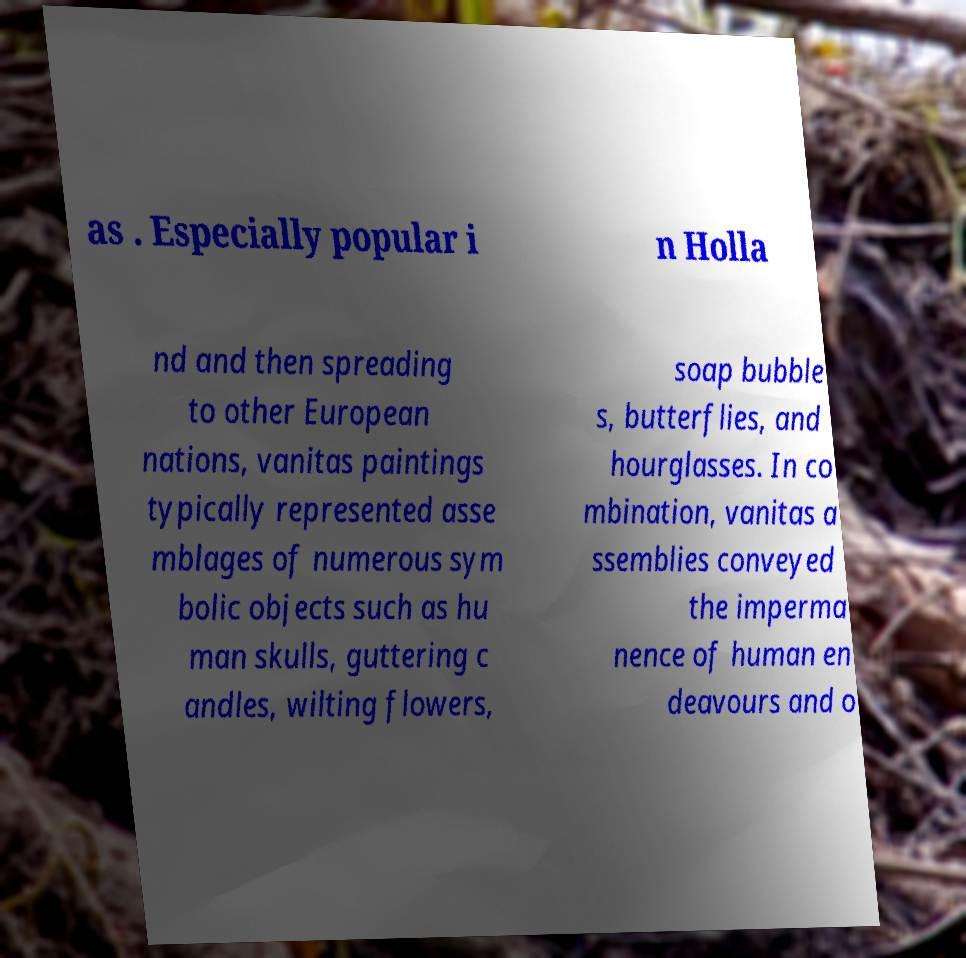Could you extract and type out the text from this image? as . Especially popular i n Holla nd and then spreading to other European nations, vanitas paintings typically represented asse mblages of numerous sym bolic objects such as hu man skulls, guttering c andles, wilting flowers, soap bubble s, butterflies, and hourglasses. In co mbination, vanitas a ssemblies conveyed the imperma nence of human en deavours and o 